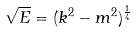<formula> <loc_0><loc_0><loc_500><loc_500>\sqrt { E } = ( k ^ { 2 } - m ^ { 2 } ) ^ { \frac { 1 } { 4 } }</formula> 